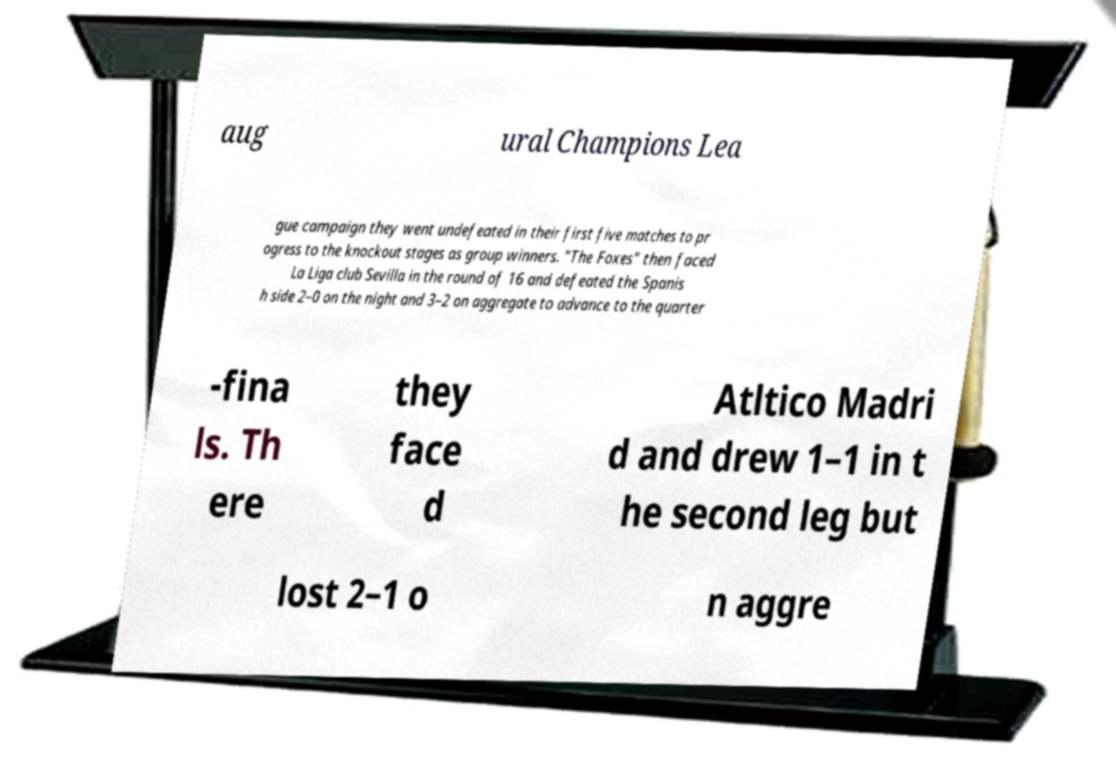Can you accurately transcribe the text from the provided image for me? aug ural Champions Lea gue campaign they went undefeated in their first five matches to pr ogress to the knockout stages as group winners. "The Foxes" then faced La Liga club Sevilla in the round of 16 and defeated the Spanis h side 2–0 on the night and 3–2 on aggregate to advance to the quarter -fina ls. Th ere they face d Atltico Madri d and drew 1–1 in t he second leg but lost 2–1 o n aggre 